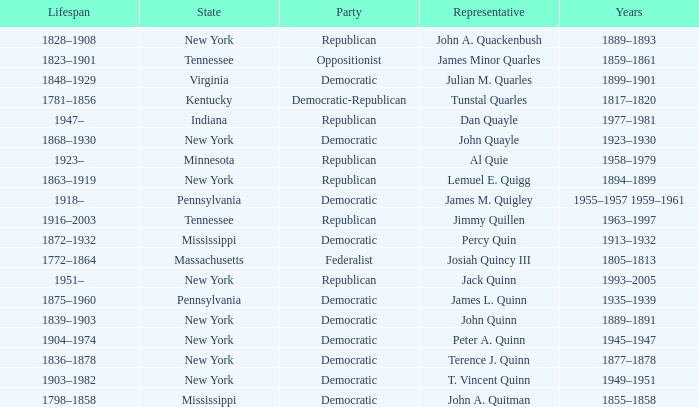Which state does Jimmy Quillen represent? Tennessee. Can you parse all the data within this table? {'header': ['Lifespan', 'State', 'Party', 'Representative', 'Years'], 'rows': [['1828–1908', 'New York', 'Republican', 'John A. Quackenbush', '1889–1893'], ['1823–1901', 'Tennessee', 'Oppositionist', 'James Minor Quarles', '1859–1861'], ['1848–1929', 'Virginia', 'Democratic', 'Julian M. Quarles', '1899–1901'], ['1781–1856', 'Kentucky', 'Democratic-Republican', 'Tunstal Quarles', '1817–1820'], ['1947–', 'Indiana', 'Republican', 'Dan Quayle', '1977–1981'], ['1868–1930', 'New York', 'Democratic', 'John Quayle', '1923–1930'], ['1923–', 'Minnesota', 'Republican', 'Al Quie', '1958–1979'], ['1863–1919', 'New York', 'Republican', 'Lemuel E. Quigg', '1894–1899'], ['1918–', 'Pennsylvania', 'Democratic', 'James M. Quigley', '1955–1957 1959–1961'], ['1916–2003', 'Tennessee', 'Republican', 'Jimmy Quillen', '1963–1997'], ['1872–1932', 'Mississippi', 'Democratic', 'Percy Quin', '1913–1932'], ['1772–1864', 'Massachusetts', 'Federalist', 'Josiah Quincy III', '1805–1813'], ['1951–', 'New York', 'Republican', 'Jack Quinn', '1993–2005'], ['1875–1960', 'Pennsylvania', 'Democratic', 'James L. Quinn', '1935–1939'], ['1839–1903', 'New York', 'Democratic', 'John Quinn', '1889–1891'], ['1904–1974', 'New York', 'Democratic', 'Peter A. Quinn', '1945–1947'], ['1836–1878', 'New York', 'Democratic', 'Terence J. Quinn', '1877–1878'], ['1903–1982', 'New York', 'Democratic', 'T. Vincent Quinn', '1949–1951'], ['1798–1858', 'Mississippi', 'Democratic', 'John A. Quitman', '1855–1858']]} 